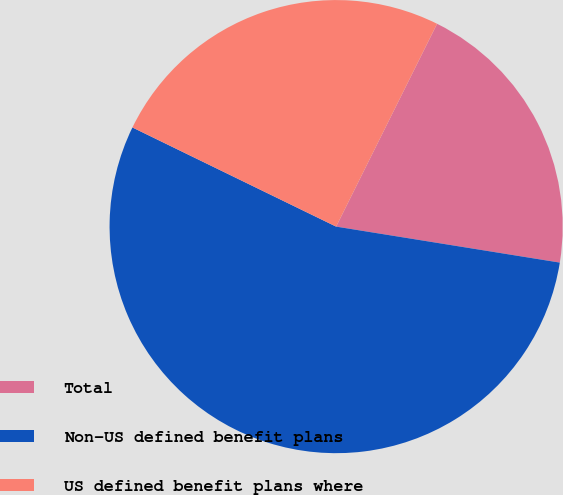Convert chart. <chart><loc_0><loc_0><loc_500><loc_500><pie_chart><fcel>Total<fcel>Non-US defined benefit plans<fcel>US defined benefit plans where<nl><fcel>20.19%<fcel>54.67%<fcel>25.14%<nl></chart> 